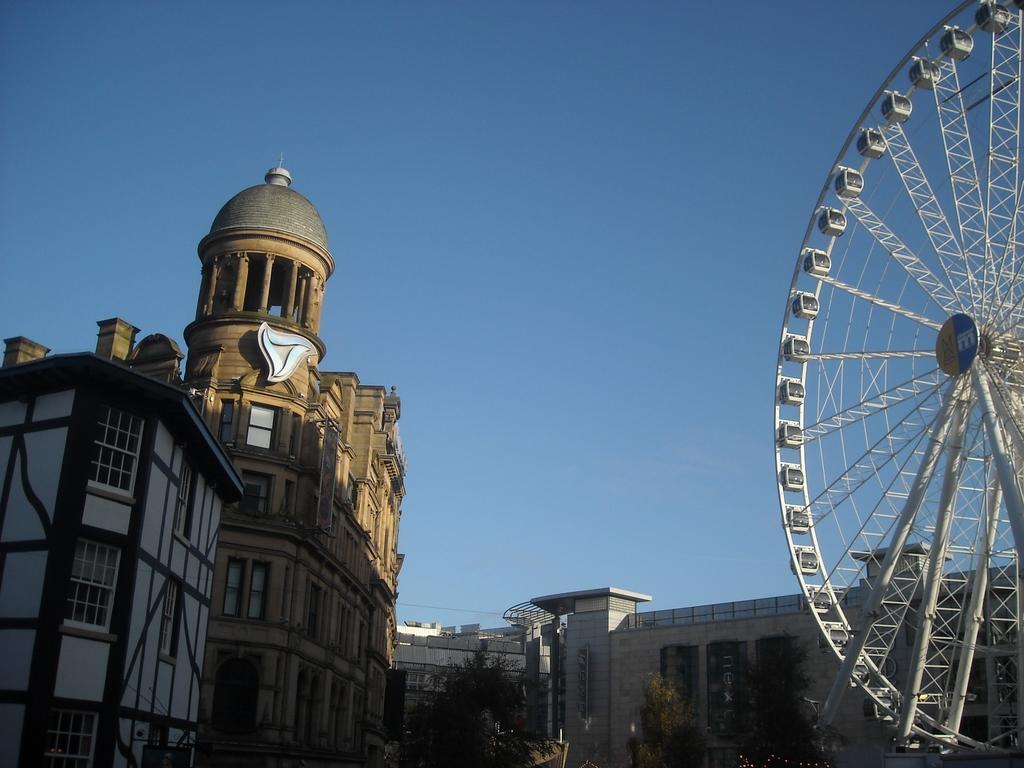In one or two sentences, can you explain what this image depicts? In this image there are buildings, trees and a joint wheel. In the background there is the sky. 